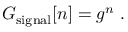Convert formula to latex. <formula><loc_0><loc_0><loc_500><loc_500>G _ { s i g n a l } [ n ] = g ^ { n } \, .</formula> 